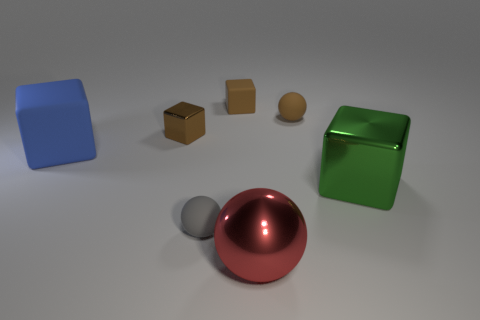Subtract all purple cubes. Subtract all red spheres. How many cubes are left? 4 Add 2 big blue matte spheres. How many objects exist? 9 Subtract all balls. How many objects are left? 4 Add 2 green metallic blocks. How many green metallic blocks exist? 3 Subtract 1 gray balls. How many objects are left? 6 Subtract all big spheres. Subtract all gray things. How many objects are left? 5 Add 6 large rubber blocks. How many large rubber blocks are left? 7 